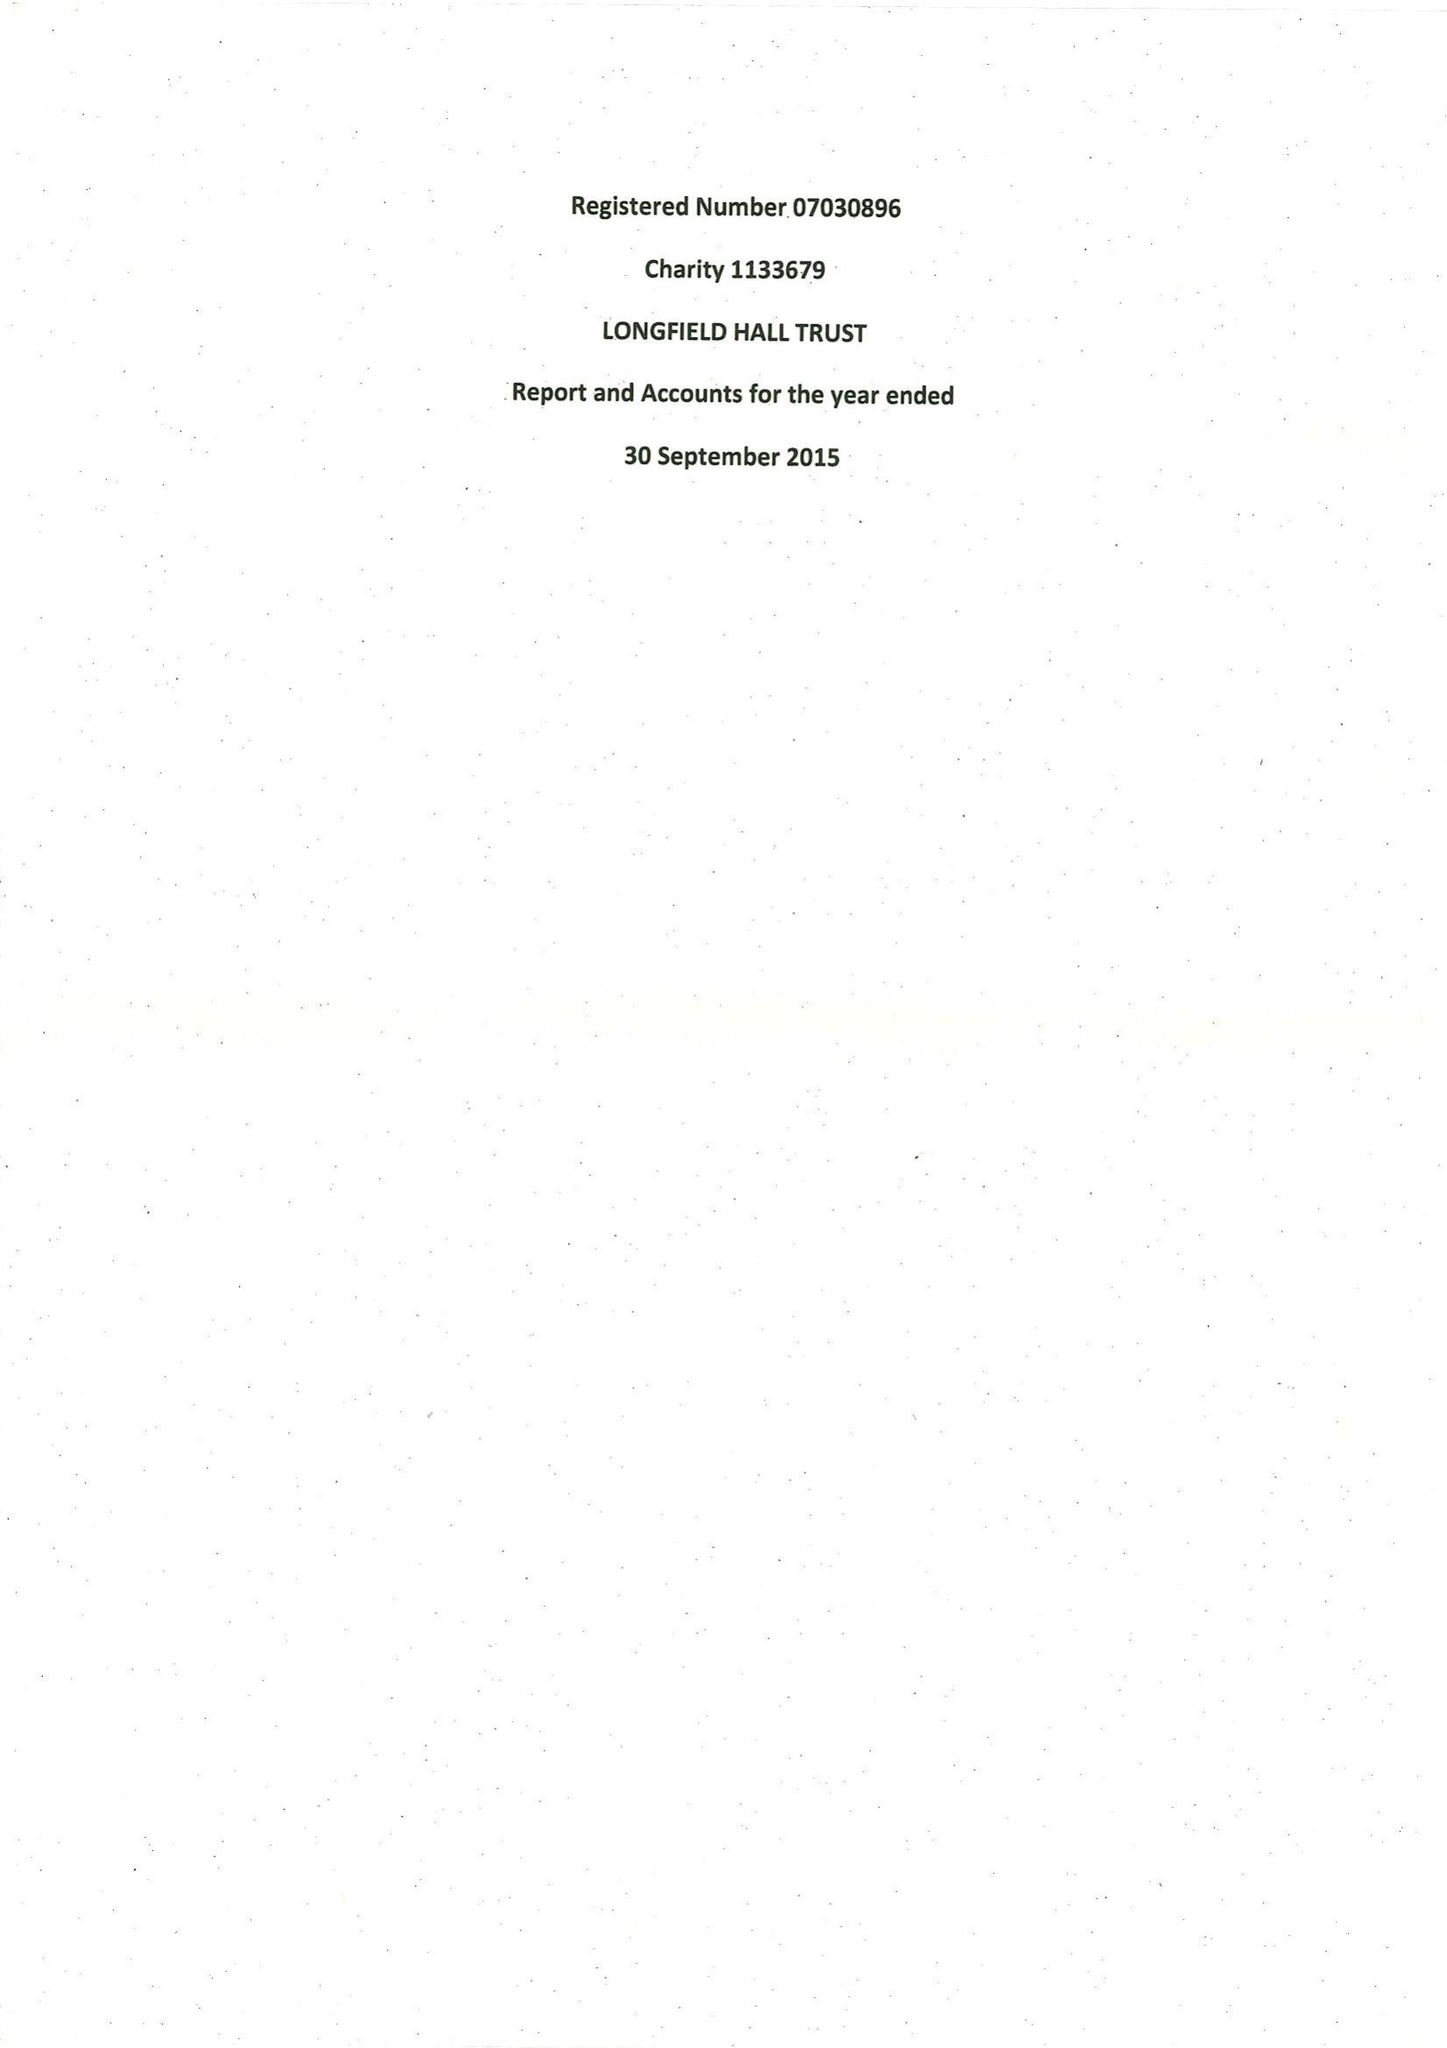What is the value for the charity_name?
Answer the question using a single word or phrase. Longfield Hall Trust 